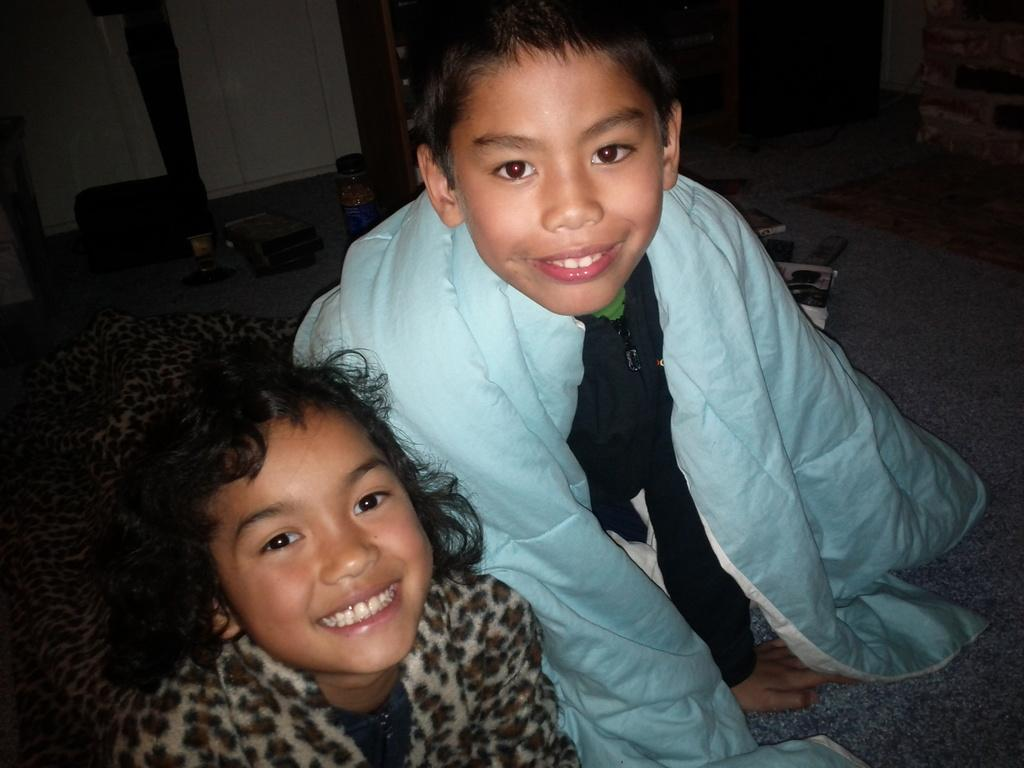How many kids are in the image? There are two kids in the image. What are the kids doing in the image? The kids are sitting and smiling. What can be seen in the background of the image? There is a bottle and a door in the background of the image. What type of sweater is the kid wearing in the image? There is no mention of a sweater in the image, so it cannot be determined what type of sweater the kid might be wearing. 